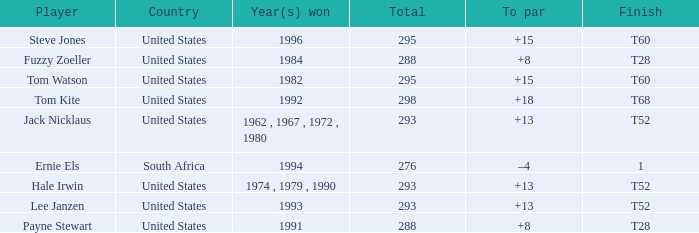What year did player steve jones, who had a t60 finish, win? 1996.0. 